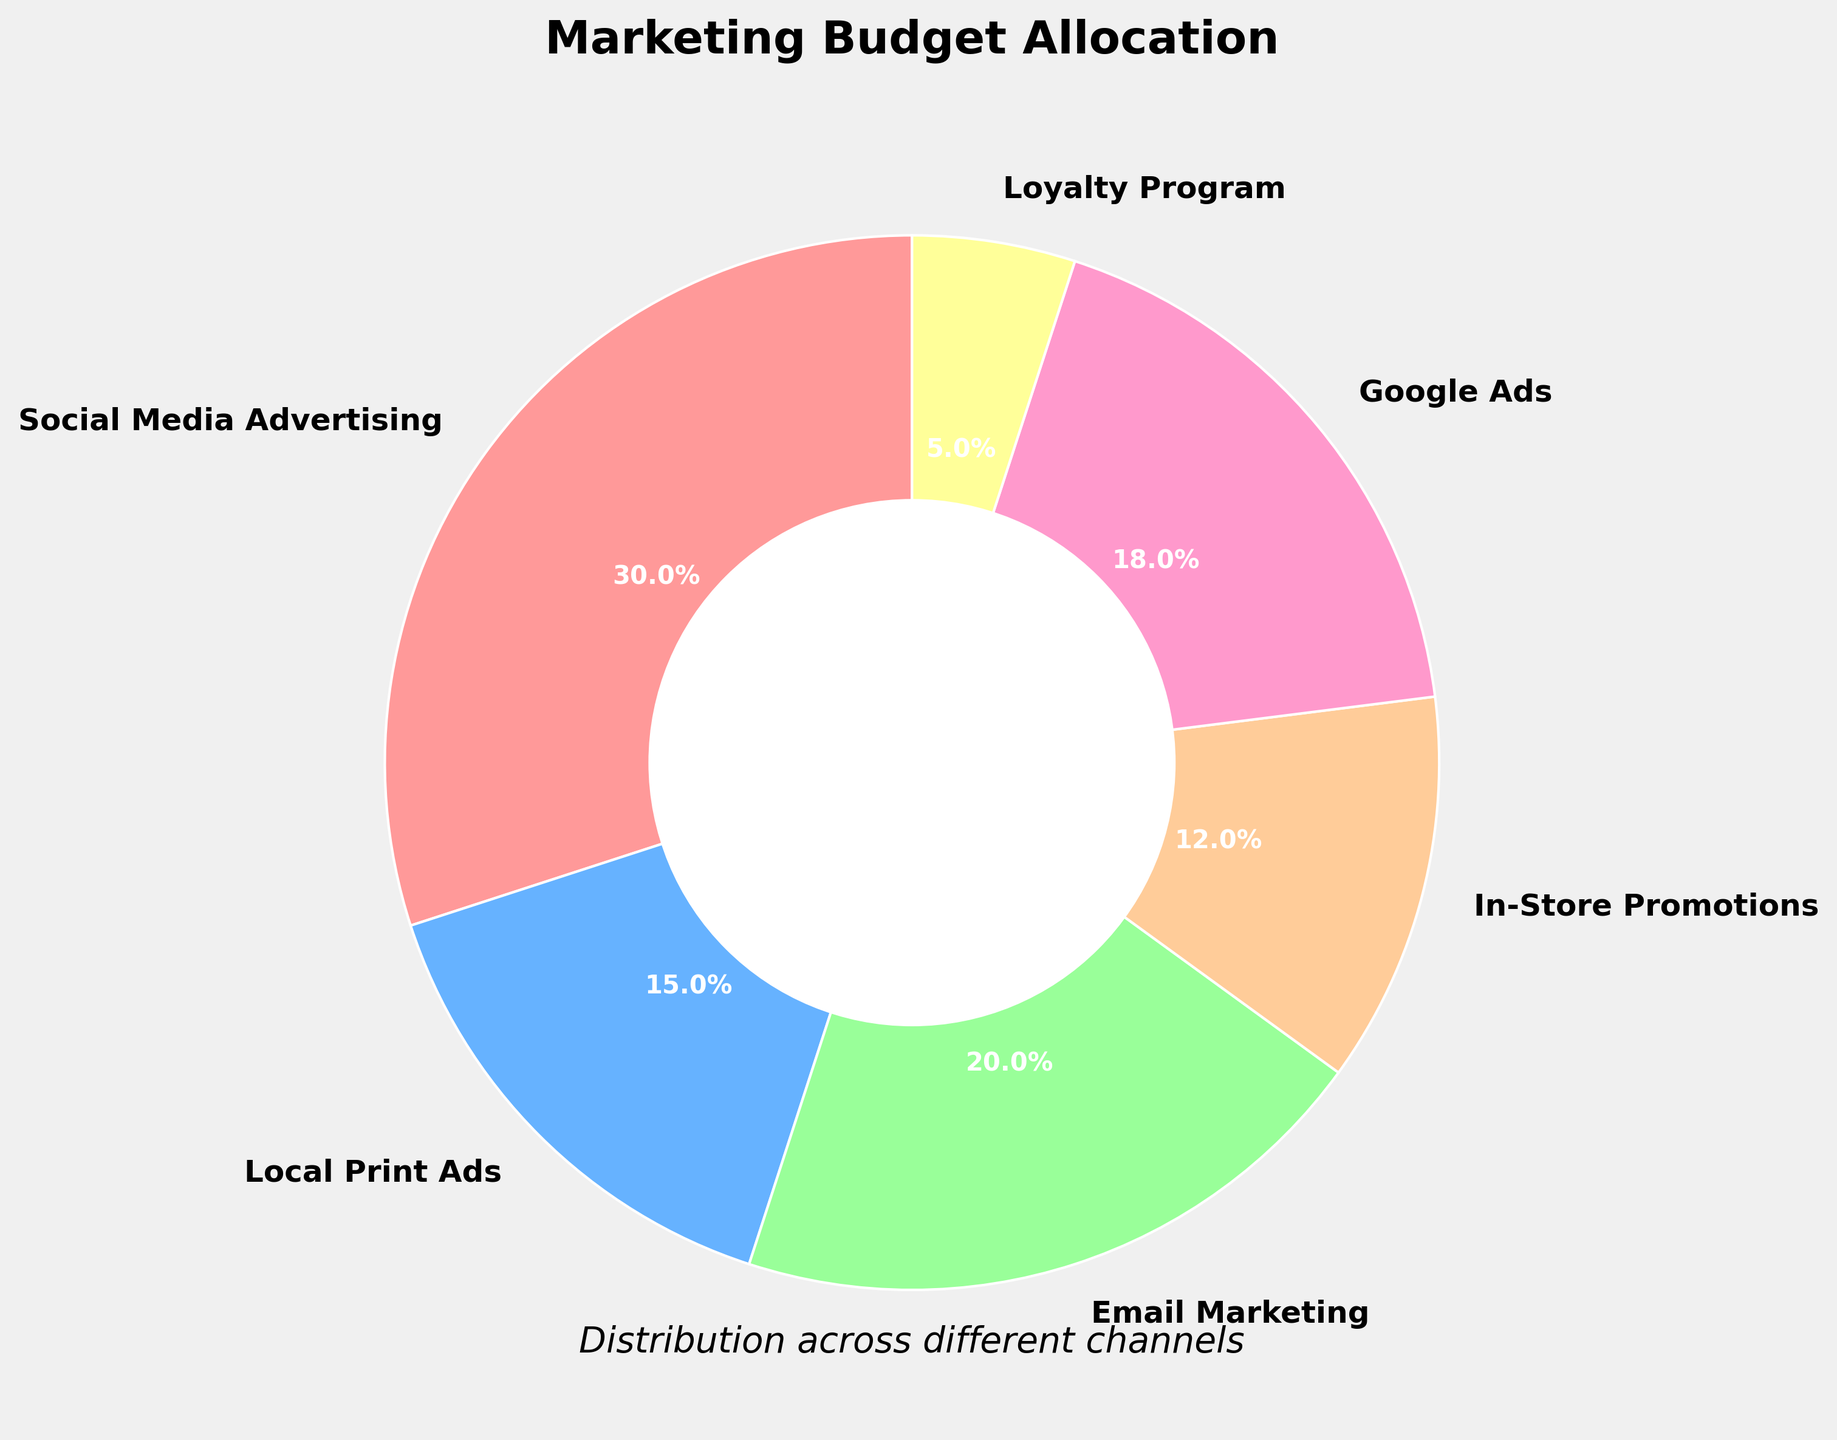Which marketing channel has the highest allocation? By looking at the pie chart, the slice labeled "Social Media Advertising" is the largest, which indicates it has the highest percentage.
Answer: Social Media Advertising What is the difference in budget allocation between Email Marketing and Local Print Ads? The percentage for Email Marketing is 20% and for Local Print Ads is 15%. The difference is 20% - 15% = 5%.
Answer: 5% What is the total percentage of the budget allocated to Google Ads and Loyalty Program combined? Add the percentages for Google Ads (18%) and Loyalty Program (5%). The total is 18% + 5% = 23%.
Answer: 23% How much more is allocated to In-Store Promotions compared to Loyalty Program? In-Store Promotions have 12% and Loyalty Program has 5%. The difference is 12% - 5% = 7%.
Answer: 7% Which channel(s) have a budget allocation of less than 10%? By observing the labels and segments of the pie chart, only the Loyalty Program has an allocation of less than 10%, which is 5%.
Answer: Loyalty Program Is the allocation for Social Media Advertising greater than the combined allocation for Local Print Ads and Email Marketing? The percentage for Social Media Advertising is 30%. The combined allocation for Local Print Ads (15%) and Email Marketing (20%) is 15% + 20% = 35%. Since 30% is less than 35%, the answer is no.
Answer: No What percentage of the budget is allocated to channels other than Social Media Advertising? Subtract the percentage of Social Media Advertising (30%) from 100%. The result is 100% - 30% = 70%.
Answer: 70% Which color represents the allocation for Google Ads in the pie chart? The pie chart uses a consistent color scheme. The slice for Google Ads is represented by a blue shade.
Answer: Blue What is the sum of the budget percentages for social media advertising and email marketing? The percentage for Social Media Advertising is 30%, and for Email Marketing is 20%. The sum is 30% + 20% = 50%.
Answer: 50% How does the allocation for in-store promotions compare to the allocation for local print ads? In-Store Promotions have a 12% allocation while Local Print Ads have a 15% allocation. In-store promotions have a smaller allocation than local print ads.
Answer: Smaller 